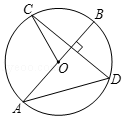Provide a description of what is shown in the illustration. The diagram exhibits a circle, designated as 'circle O', centered at point O. It includes a diameter labeled AB, which is the longest chord passing straight through the center. Perpendicular to this diameter at point D, there's a chord CD, creating right angles at the intersection. This setup suggests a focus on various geometric principles such as the properties of diameters and chords in a circle. 